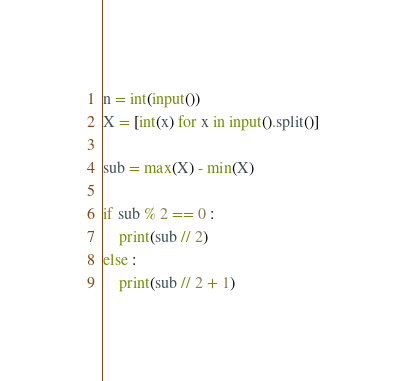Convert code to text. <code><loc_0><loc_0><loc_500><loc_500><_Python_>n = int(input())
X = [int(x) for x in input().split()]

sub = max(X) - min(X)

if sub % 2 == 0 :
    print(sub // 2)
else :
    print(sub // 2 + 1)
</code> 